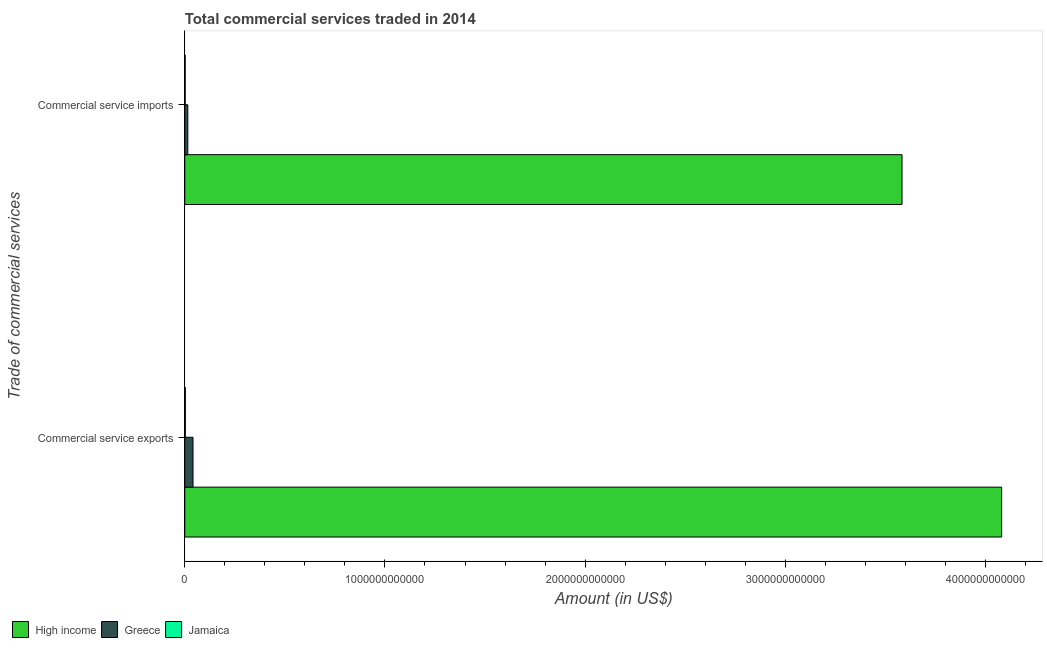How many different coloured bars are there?
Give a very brief answer. 3. How many groups of bars are there?
Give a very brief answer. 2. Are the number of bars on each tick of the Y-axis equal?
Provide a short and direct response. Yes. How many bars are there on the 1st tick from the bottom?
Your answer should be compact. 3. What is the label of the 2nd group of bars from the top?
Make the answer very short. Commercial service exports. What is the amount of commercial service exports in Greece?
Ensure brevity in your answer.  4.11e+1. Across all countries, what is the maximum amount of commercial service exports?
Your answer should be compact. 4.08e+12. Across all countries, what is the minimum amount of commercial service exports?
Your answer should be very brief. 2.79e+09. In which country was the amount of commercial service imports maximum?
Your answer should be compact. High income. In which country was the amount of commercial service exports minimum?
Provide a short and direct response. Jamaica. What is the total amount of commercial service exports in the graph?
Provide a succinct answer. 4.12e+12. What is the difference between the amount of commercial service exports in Jamaica and that in High income?
Offer a very short reply. -4.08e+12. What is the difference between the amount of commercial service exports in Jamaica and the amount of commercial service imports in High income?
Make the answer very short. -3.58e+12. What is the average amount of commercial service imports per country?
Make the answer very short. 1.20e+12. What is the difference between the amount of commercial service exports and amount of commercial service imports in Jamaica?
Ensure brevity in your answer.  6.96e+08. In how many countries, is the amount of commercial service exports greater than 600000000000 US$?
Your answer should be compact. 1. What is the ratio of the amount of commercial service imports in High income to that in Jamaica?
Offer a terse response. 1709.09. Is the amount of commercial service exports in High income less than that in Jamaica?
Offer a very short reply. No. What does the 1st bar from the top in Commercial service exports represents?
Give a very brief answer. Jamaica. What does the 3rd bar from the bottom in Commercial service imports represents?
Your response must be concise. Jamaica. Are all the bars in the graph horizontal?
Your answer should be compact. Yes. What is the difference between two consecutive major ticks on the X-axis?
Give a very brief answer. 1.00e+12. Where does the legend appear in the graph?
Your response must be concise. Bottom left. How are the legend labels stacked?
Your response must be concise. Horizontal. What is the title of the graph?
Offer a very short reply. Total commercial services traded in 2014. What is the label or title of the Y-axis?
Your response must be concise. Trade of commercial services. What is the Amount (in US$) of High income in Commercial service exports?
Make the answer very short. 4.08e+12. What is the Amount (in US$) in Greece in Commercial service exports?
Provide a succinct answer. 4.11e+1. What is the Amount (in US$) of Jamaica in Commercial service exports?
Your answer should be very brief. 2.79e+09. What is the Amount (in US$) in High income in Commercial service imports?
Provide a short and direct response. 3.58e+12. What is the Amount (in US$) of Greece in Commercial service imports?
Ensure brevity in your answer.  1.51e+1. What is the Amount (in US$) of Jamaica in Commercial service imports?
Your answer should be compact. 2.10e+09. Across all Trade of commercial services, what is the maximum Amount (in US$) of High income?
Your answer should be compact. 4.08e+12. Across all Trade of commercial services, what is the maximum Amount (in US$) of Greece?
Offer a very short reply. 4.11e+1. Across all Trade of commercial services, what is the maximum Amount (in US$) of Jamaica?
Your answer should be compact. 2.79e+09. Across all Trade of commercial services, what is the minimum Amount (in US$) of High income?
Offer a terse response. 3.58e+12. Across all Trade of commercial services, what is the minimum Amount (in US$) of Greece?
Your answer should be compact. 1.51e+1. Across all Trade of commercial services, what is the minimum Amount (in US$) in Jamaica?
Provide a succinct answer. 2.10e+09. What is the total Amount (in US$) in High income in the graph?
Make the answer very short. 7.66e+12. What is the total Amount (in US$) in Greece in the graph?
Ensure brevity in your answer.  5.63e+1. What is the total Amount (in US$) in Jamaica in the graph?
Provide a succinct answer. 4.89e+09. What is the difference between the Amount (in US$) in High income in Commercial service exports and that in Commercial service imports?
Provide a short and direct response. 4.98e+11. What is the difference between the Amount (in US$) of Greece in Commercial service exports and that in Commercial service imports?
Provide a succinct answer. 2.60e+1. What is the difference between the Amount (in US$) of Jamaica in Commercial service exports and that in Commercial service imports?
Keep it short and to the point. 6.96e+08. What is the difference between the Amount (in US$) in High income in Commercial service exports and the Amount (in US$) in Greece in Commercial service imports?
Keep it short and to the point. 4.07e+12. What is the difference between the Amount (in US$) in High income in Commercial service exports and the Amount (in US$) in Jamaica in Commercial service imports?
Your answer should be compact. 4.08e+12. What is the difference between the Amount (in US$) in Greece in Commercial service exports and the Amount (in US$) in Jamaica in Commercial service imports?
Give a very brief answer. 3.90e+1. What is the average Amount (in US$) in High income per Trade of commercial services?
Offer a very short reply. 3.83e+12. What is the average Amount (in US$) in Greece per Trade of commercial services?
Make the answer very short. 2.81e+1. What is the average Amount (in US$) of Jamaica per Trade of commercial services?
Give a very brief answer. 2.44e+09. What is the difference between the Amount (in US$) in High income and Amount (in US$) in Greece in Commercial service exports?
Make the answer very short. 4.04e+12. What is the difference between the Amount (in US$) of High income and Amount (in US$) of Jamaica in Commercial service exports?
Provide a short and direct response. 4.08e+12. What is the difference between the Amount (in US$) in Greece and Amount (in US$) in Jamaica in Commercial service exports?
Your answer should be very brief. 3.84e+1. What is the difference between the Amount (in US$) of High income and Amount (in US$) of Greece in Commercial service imports?
Provide a succinct answer. 3.57e+12. What is the difference between the Amount (in US$) in High income and Amount (in US$) in Jamaica in Commercial service imports?
Make the answer very short. 3.58e+12. What is the difference between the Amount (in US$) in Greece and Amount (in US$) in Jamaica in Commercial service imports?
Your answer should be compact. 1.30e+1. What is the ratio of the Amount (in US$) of High income in Commercial service exports to that in Commercial service imports?
Keep it short and to the point. 1.14. What is the ratio of the Amount (in US$) in Greece in Commercial service exports to that in Commercial service imports?
Provide a short and direct response. 2.72. What is the ratio of the Amount (in US$) in Jamaica in Commercial service exports to that in Commercial service imports?
Keep it short and to the point. 1.33. What is the difference between the highest and the second highest Amount (in US$) of High income?
Make the answer very short. 4.98e+11. What is the difference between the highest and the second highest Amount (in US$) of Greece?
Ensure brevity in your answer.  2.60e+1. What is the difference between the highest and the second highest Amount (in US$) in Jamaica?
Offer a terse response. 6.96e+08. What is the difference between the highest and the lowest Amount (in US$) in High income?
Make the answer very short. 4.98e+11. What is the difference between the highest and the lowest Amount (in US$) in Greece?
Offer a terse response. 2.60e+1. What is the difference between the highest and the lowest Amount (in US$) of Jamaica?
Ensure brevity in your answer.  6.96e+08. 